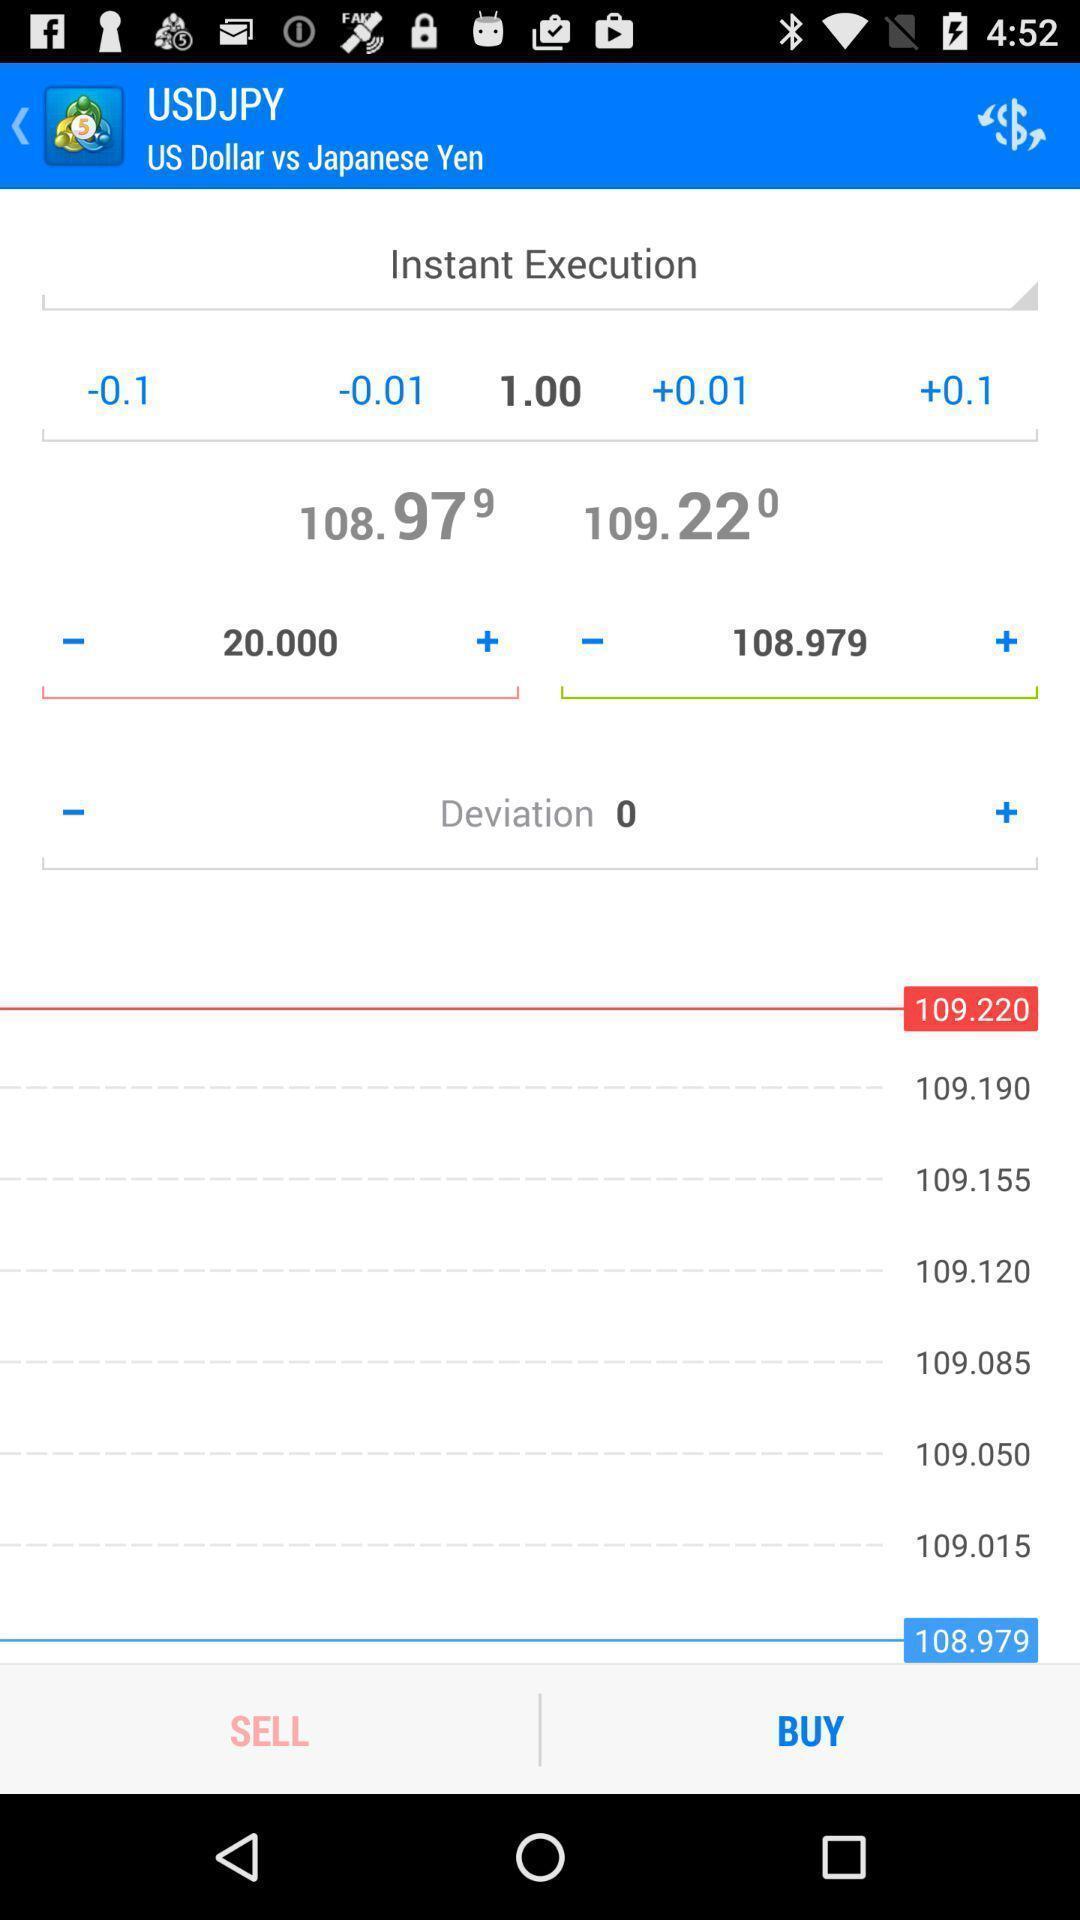What can you discern from this picture? Page showing details about the currency. 